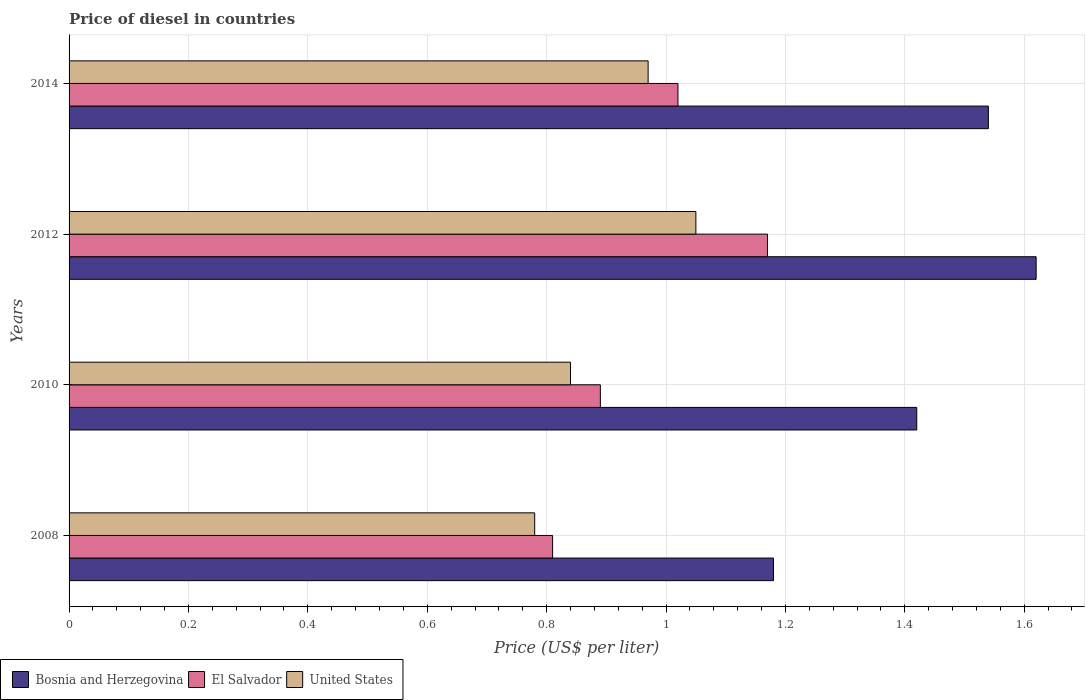How many different coloured bars are there?
Provide a short and direct response. 3. How many groups of bars are there?
Your response must be concise. 4. What is the label of the 1st group of bars from the top?
Provide a succinct answer. 2014. In how many cases, is the number of bars for a given year not equal to the number of legend labels?
Provide a succinct answer. 0. What is the price of diesel in El Salvador in 2014?
Offer a very short reply. 1.02. Across all years, what is the maximum price of diesel in El Salvador?
Keep it short and to the point. 1.17. Across all years, what is the minimum price of diesel in El Salvador?
Provide a short and direct response. 0.81. What is the total price of diesel in United States in the graph?
Provide a short and direct response. 3.64. What is the difference between the price of diesel in Bosnia and Herzegovina in 2008 and that in 2014?
Provide a succinct answer. -0.36. What is the difference between the price of diesel in United States in 2010 and the price of diesel in El Salvador in 2014?
Offer a terse response. -0.18. What is the average price of diesel in Bosnia and Herzegovina per year?
Make the answer very short. 1.44. In the year 2012, what is the difference between the price of diesel in Bosnia and Herzegovina and price of diesel in United States?
Offer a very short reply. 0.57. What is the ratio of the price of diesel in United States in 2010 to that in 2012?
Ensure brevity in your answer.  0.8. Is the price of diesel in El Salvador in 2008 less than that in 2010?
Provide a succinct answer. Yes. Is the difference between the price of diesel in Bosnia and Herzegovina in 2008 and 2014 greater than the difference between the price of diesel in United States in 2008 and 2014?
Ensure brevity in your answer.  No. What is the difference between the highest and the second highest price of diesel in United States?
Your response must be concise. 0.08. What is the difference between the highest and the lowest price of diesel in Bosnia and Herzegovina?
Offer a terse response. 0.44. In how many years, is the price of diesel in Bosnia and Herzegovina greater than the average price of diesel in Bosnia and Herzegovina taken over all years?
Offer a terse response. 2. Is the sum of the price of diesel in United States in 2008 and 2010 greater than the maximum price of diesel in El Salvador across all years?
Give a very brief answer. Yes. What does the 2nd bar from the top in 2014 represents?
Provide a succinct answer. El Salvador. What does the 1st bar from the bottom in 2014 represents?
Your response must be concise. Bosnia and Herzegovina. What is the difference between two consecutive major ticks on the X-axis?
Offer a terse response. 0.2. Are the values on the major ticks of X-axis written in scientific E-notation?
Provide a succinct answer. No. Does the graph contain any zero values?
Provide a short and direct response. No. Does the graph contain grids?
Your response must be concise. Yes. What is the title of the graph?
Offer a terse response. Price of diesel in countries. Does "Channel Islands" appear as one of the legend labels in the graph?
Give a very brief answer. No. What is the label or title of the X-axis?
Offer a very short reply. Price (US$ per liter). What is the label or title of the Y-axis?
Offer a terse response. Years. What is the Price (US$ per liter) of Bosnia and Herzegovina in 2008?
Keep it short and to the point. 1.18. What is the Price (US$ per liter) in El Salvador in 2008?
Your response must be concise. 0.81. What is the Price (US$ per liter) in United States in 2008?
Ensure brevity in your answer.  0.78. What is the Price (US$ per liter) in Bosnia and Herzegovina in 2010?
Give a very brief answer. 1.42. What is the Price (US$ per liter) of El Salvador in 2010?
Your answer should be compact. 0.89. What is the Price (US$ per liter) of United States in 2010?
Provide a short and direct response. 0.84. What is the Price (US$ per liter) of Bosnia and Herzegovina in 2012?
Give a very brief answer. 1.62. What is the Price (US$ per liter) in El Salvador in 2012?
Provide a short and direct response. 1.17. What is the Price (US$ per liter) of Bosnia and Herzegovina in 2014?
Offer a very short reply. 1.54. What is the Price (US$ per liter) in El Salvador in 2014?
Your response must be concise. 1.02. Across all years, what is the maximum Price (US$ per liter) of Bosnia and Herzegovina?
Provide a short and direct response. 1.62. Across all years, what is the maximum Price (US$ per liter) in El Salvador?
Give a very brief answer. 1.17. Across all years, what is the minimum Price (US$ per liter) in Bosnia and Herzegovina?
Offer a very short reply. 1.18. Across all years, what is the minimum Price (US$ per liter) of El Salvador?
Offer a terse response. 0.81. Across all years, what is the minimum Price (US$ per liter) of United States?
Keep it short and to the point. 0.78. What is the total Price (US$ per liter) in Bosnia and Herzegovina in the graph?
Keep it short and to the point. 5.76. What is the total Price (US$ per liter) of El Salvador in the graph?
Your answer should be very brief. 3.89. What is the total Price (US$ per liter) in United States in the graph?
Make the answer very short. 3.64. What is the difference between the Price (US$ per liter) of Bosnia and Herzegovina in 2008 and that in 2010?
Your response must be concise. -0.24. What is the difference between the Price (US$ per liter) in El Salvador in 2008 and that in 2010?
Offer a very short reply. -0.08. What is the difference between the Price (US$ per liter) in United States in 2008 and that in 2010?
Provide a short and direct response. -0.06. What is the difference between the Price (US$ per liter) in Bosnia and Herzegovina in 2008 and that in 2012?
Your response must be concise. -0.44. What is the difference between the Price (US$ per liter) in El Salvador in 2008 and that in 2012?
Ensure brevity in your answer.  -0.36. What is the difference between the Price (US$ per liter) of United States in 2008 and that in 2012?
Your response must be concise. -0.27. What is the difference between the Price (US$ per liter) in Bosnia and Herzegovina in 2008 and that in 2014?
Offer a terse response. -0.36. What is the difference between the Price (US$ per liter) of El Salvador in 2008 and that in 2014?
Your answer should be compact. -0.21. What is the difference between the Price (US$ per liter) of United States in 2008 and that in 2014?
Provide a short and direct response. -0.19. What is the difference between the Price (US$ per liter) of El Salvador in 2010 and that in 2012?
Your response must be concise. -0.28. What is the difference between the Price (US$ per liter) of United States in 2010 and that in 2012?
Provide a short and direct response. -0.21. What is the difference between the Price (US$ per liter) of Bosnia and Herzegovina in 2010 and that in 2014?
Ensure brevity in your answer.  -0.12. What is the difference between the Price (US$ per liter) of El Salvador in 2010 and that in 2014?
Give a very brief answer. -0.13. What is the difference between the Price (US$ per liter) in United States in 2010 and that in 2014?
Ensure brevity in your answer.  -0.13. What is the difference between the Price (US$ per liter) of Bosnia and Herzegovina in 2012 and that in 2014?
Keep it short and to the point. 0.08. What is the difference between the Price (US$ per liter) of El Salvador in 2012 and that in 2014?
Ensure brevity in your answer.  0.15. What is the difference between the Price (US$ per liter) in Bosnia and Herzegovina in 2008 and the Price (US$ per liter) in El Salvador in 2010?
Make the answer very short. 0.29. What is the difference between the Price (US$ per liter) of Bosnia and Herzegovina in 2008 and the Price (US$ per liter) of United States in 2010?
Your answer should be very brief. 0.34. What is the difference between the Price (US$ per liter) in El Salvador in 2008 and the Price (US$ per liter) in United States in 2010?
Make the answer very short. -0.03. What is the difference between the Price (US$ per liter) in Bosnia and Herzegovina in 2008 and the Price (US$ per liter) in United States in 2012?
Provide a succinct answer. 0.13. What is the difference between the Price (US$ per liter) in El Salvador in 2008 and the Price (US$ per liter) in United States in 2012?
Keep it short and to the point. -0.24. What is the difference between the Price (US$ per liter) of Bosnia and Herzegovina in 2008 and the Price (US$ per liter) of El Salvador in 2014?
Make the answer very short. 0.16. What is the difference between the Price (US$ per liter) in Bosnia and Herzegovina in 2008 and the Price (US$ per liter) in United States in 2014?
Ensure brevity in your answer.  0.21. What is the difference between the Price (US$ per liter) in El Salvador in 2008 and the Price (US$ per liter) in United States in 2014?
Provide a succinct answer. -0.16. What is the difference between the Price (US$ per liter) of Bosnia and Herzegovina in 2010 and the Price (US$ per liter) of El Salvador in 2012?
Ensure brevity in your answer.  0.25. What is the difference between the Price (US$ per liter) of Bosnia and Herzegovina in 2010 and the Price (US$ per liter) of United States in 2012?
Ensure brevity in your answer.  0.37. What is the difference between the Price (US$ per liter) in El Salvador in 2010 and the Price (US$ per liter) in United States in 2012?
Offer a terse response. -0.16. What is the difference between the Price (US$ per liter) in Bosnia and Herzegovina in 2010 and the Price (US$ per liter) in United States in 2014?
Keep it short and to the point. 0.45. What is the difference between the Price (US$ per liter) of El Salvador in 2010 and the Price (US$ per liter) of United States in 2014?
Ensure brevity in your answer.  -0.08. What is the difference between the Price (US$ per liter) in Bosnia and Herzegovina in 2012 and the Price (US$ per liter) in El Salvador in 2014?
Provide a short and direct response. 0.6. What is the difference between the Price (US$ per liter) in Bosnia and Herzegovina in 2012 and the Price (US$ per liter) in United States in 2014?
Ensure brevity in your answer.  0.65. What is the average Price (US$ per liter) in Bosnia and Herzegovina per year?
Provide a succinct answer. 1.44. What is the average Price (US$ per liter) in El Salvador per year?
Provide a short and direct response. 0.97. What is the average Price (US$ per liter) of United States per year?
Offer a very short reply. 0.91. In the year 2008, what is the difference between the Price (US$ per liter) of Bosnia and Herzegovina and Price (US$ per liter) of El Salvador?
Provide a succinct answer. 0.37. In the year 2008, what is the difference between the Price (US$ per liter) of Bosnia and Herzegovina and Price (US$ per liter) of United States?
Keep it short and to the point. 0.4. In the year 2010, what is the difference between the Price (US$ per liter) in Bosnia and Herzegovina and Price (US$ per liter) in El Salvador?
Make the answer very short. 0.53. In the year 2010, what is the difference between the Price (US$ per liter) in Bosnia and Herzegovina and Price (US$ per liter) in United States?
Make the answer very short. 0.58. In the year 2010, what is the difference between the Price (US$ per liter) in El Salvador and Price (US$ per liter) in United States?
Your answer should be very brief. 0.05. In the year 2012, what is the difference between the Price (US$ per liter) in Bosnia and Herzegovina and Price (US$ per liter) in El Salvador?
Make the answer very short. 0.45. In the year 2012, what is the difference between the Price (US$ per liter) in Bosnia and Herzegovina and Price (US$ per liter) in United States?
Keep it short and to the point. 0.57. In the year 2012, what is the difference between the Price (US$ per liter) in El Salvador and Price (US$ per liter) in United States?
Provide a succinct answer. 0.12. In the year 2014, what is the difference between the Price (US$ per liter) in Bosnia and Herzegovina and Price (US$ per liter) in El Salvador?
Offer a very short reply. 0.52. In the year 2014, what is the difference between the Price (US$ per liter) of Bosnia and Herzegovina and Price (US$ per liter) of United States?
Your answer should be compact. 0.57. In the year 2014, what is the difference between the Price (US$ per liter) in El Salvador and Price (US$ per liter) in United States?
Keep it short and to the point. 0.05. What is the ratio of the Price (US$ per liter) in Bosnia and Herzegovina in 2008 to that in 2010?
Offer a terse response. 0.83. What is the ratio of the Price (US$ per liter) of El Salvador in 2008 to that in 2010?
Make the answer very short. 0.91. What is the ratio of the Price (US$ per liter) in United States in 2008 to that in 2010?
Keep it short and to the point. 0.93. What is the ratio of the Price (US$ per liter) in Bosnia and Herzegovina in 2008 to that in 2012?
Your response must be concise. 0.73. What is the ratio of the Price (US$ per liter) of El Salvador in 2008 to that in 2012?
Your answer should be compact. 0.69. What is the ratio of the Price (US$ per liter) in United States in 2008 to that in 2012?
Give a very brief answer. 0.74. What is the ratio of the Price (US$ per liter) in Bosnia and Herzegovina in 2008 to that in 2014?
Your answer should be compact. 0.77. What is the ratio of the Price (US$ per liter) in El Salvador in 2008 to that in 2014?
Offer a very short reply. 0.79. What is the ratio of the Price (US$ per liter) of United States in 2008 to that in 2014?
Keep it short and to the point. 0.8. What is the ratio of the Price (US$ per liter) in Bosnia and Herzegovina in 2010 to that in 2012?
Provide a short and direct response. 0.88. What is the ratio of the Price (US$ per liter) in El Salvador in 2010 to that in 2012?
Your answer should be very brief. 0.76. What is the ratio of the Price (US$ per liter) of Bosnia and Herzegovina in 2010 to that in 2014?
Your answer should be compact. 0.92. What is the ratio of the Price (US$ per liter) of El Salvador in 2010 to that in 2014?
Provide a short and direct response. 0.87. What is the ratio of the Price (US$ per liter) of United States in 2010 to that in 2014?
Offer a very short reply. 0.87. What is the ratio of the Price (US$ per liter) in Bosnia and Herzegovina in 2012 to that in 2014?
Make the answer very short. 1.05. What is the ratio of the Price (US$ per liter) of El Salvador in 2012 to that in 2014?
Offer a terse response. 1.15. What is the ratio of the Price (US$ per liter) of United States in 2012 to that in 2014?
Offer a very short reply. 1.08. What is the difference between the highest and the second highest Price (US$ per liter) of Bosnia and Herzegovina?
Make the answer very short. 0.08. What is the difference between the highest and the lowest Price (US$ per liter) in Bosnia and Herzegovina?
Offer a very short reply. 0.44. What is the difference between the highest and the lowest Price (US$ per liter) of El Salvador?
Your answer should be very brief. 0.36. What is the difference between the highest and the lowest Price (US$ per liter) in United States?
Your answer should be compact. 0.27. 